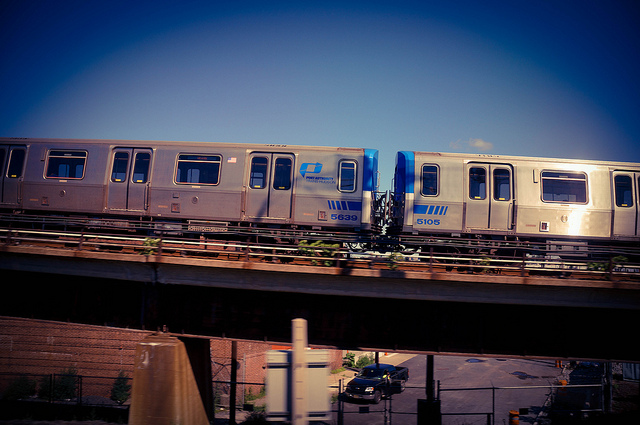Please transcribe the text information in this image. 5639 5105 